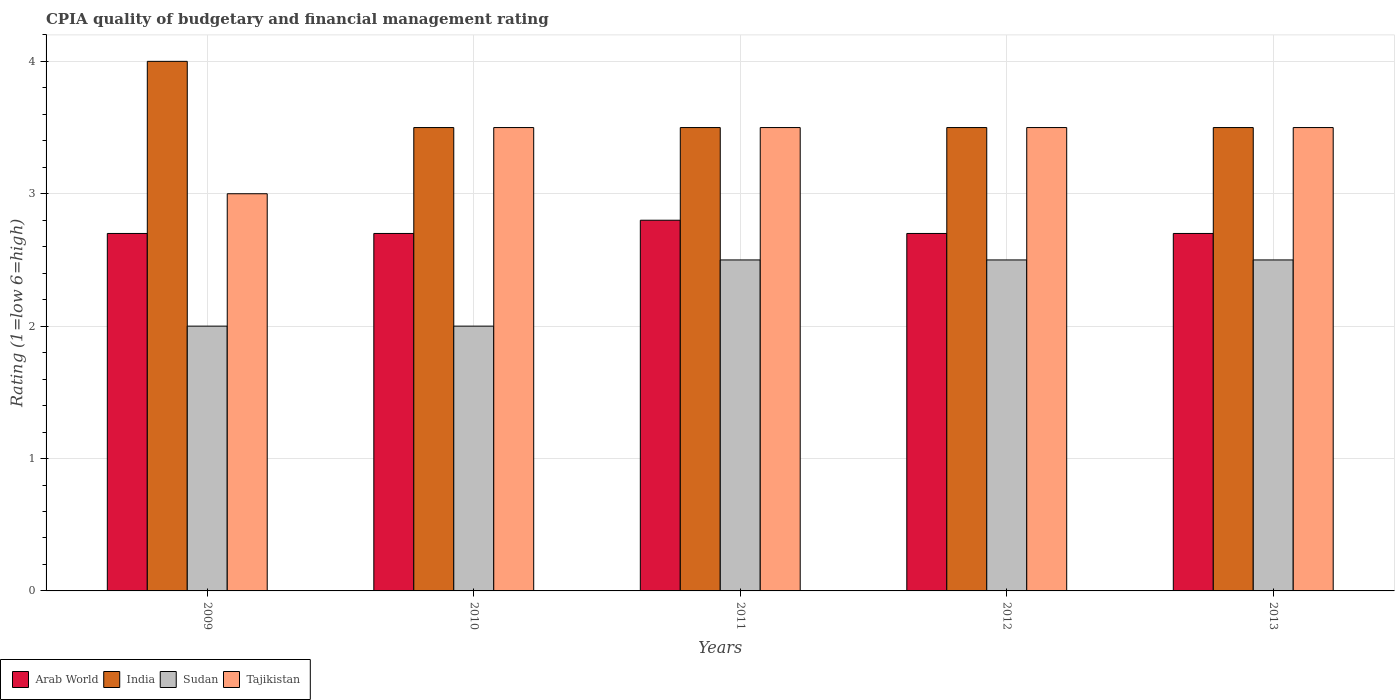How many groups of bars are there?
Make the answer very short. 5. How many bars are there on the 4th tick from the left?
Keep it short and to the point. 4. How many bars are there on the 1st tick from the right?
Your answer should be compact. 4. In how many cases, is the number of bars for a given year not equal to the number of legend labels?
Offer a very short reply. 0. Across all years, what is the minimum CPIA rating in Tajikistan?
Ensure brevity in your answer.  3. In which year was the CPIA rating in India maximum?
Offer a very short reply. 2009. What is the total CPIA rating in Tajikistan in the graph?
Give a very brief answer. 17. What is the difference between the CPIA rating in India in 2010 and that in 2013?
Provide a succinct answer. 0. What is the difference between the CPIA rating in India in 2012 and the CPIA rating in Arab World in 2013?
Make the answer very short. 0.8. What is the ratio of the CPIA rating in Tajikistan in 2009 to that in 2011?
Offer a very short reply. 0.86. Is the CPIA rating in Tajikistan in 2011 less than that in 2013?
Make the answer very short. No. Is the difference between the CPIA rating in Sudan in 2009 and 2011 greater than the difference between the CPIA rating in India in 2009 and 2011?
Give a very brief answer. No. What is the difference between the highest and the second highest CPIA rating in Arab World?
Provide a short and direct response. 0.1. Is it the case that in every year, the sum of the CPIA rating in Arab World and CPIA rating in Sudan is greater than the sum of CPIA rating in India and CPIA rating in Tajikistan?
Ensure brevity in your answer.  No. What does the 4th bar from the left in 2009 represents?
Provide a succinct answer. Tajikistan. What does the 2nd bar from the right in 2010 represents?
Offer a terse response. Sudan. How many years are there in the graph?
Provide a succinct answer. 5. What is the difference between two consecutive major ticks on the Y-axis?
Offer a very short reply. 1. Does the graph contain any zero values?
Offer a terse response. No. Where does the legend appear in the graph?
Give a very brief answer. Bottom left. What is the title of the graph?
Make the answer very short. CPIA quality of budgetary and financial management rating. Does "Luxembourg" appear as one of the legend labels in the graph?
Ensure brevity in your answer.  No. What is the label or title of the Y-axis?
Your answer should be compact. Rating (1=low 6=high). What is the Rating (1=low 6=high) of Arab World in 2009?
Offer a terse response. 2.7. What is the Rating (1=low 6=high) in India in 2009?
Your answer should be compact. 4. What is the Rating (1=low 6=high) of Sudan in 2009?
Your answer should be compact. 2. What is the Rating (1=low 6=high) of Arab World in 2010?
Your response must be concise. 2.7. What is the Rating (1=low 6=high) of India in 2010?
Give a very brief answer. 3.5. What is the Rating (1=low 6=high) in Sudan in 2010?
Your answer should be compact. 2. What is the Rating (1=low 6=high) in Tajikistan in 2010?
Ensure brevity in your answer.  3.5. What is the Rating (1=low 6=high) in India in 2011?
Your answer should be compact. 3.5. What is the Rating (1=low 6=high) of Sudan in 2011?
Provide a short and direct response. 2.5. What is the Rating (1=low 6=high) in Tajikistan in 2011?
Ensure brevity in your answer.  3.5. What is the Rating (1=low 6=high) in Sudan in 2012?
Keep it short and to the point. 2.5. What is the Rating (1=low 6=high) of Tajikistan in 2012?
Make the answer very short. 3.5. What is the Rating (1=low 6=high) of Arab World in 2013?
Make the answer very short. 2.7. What is the Rating (1=low 6=high) of India in 2013?
Provide a succinct answer. 3.5. Across all years, what is the maximum Rating (1=low 6=high) of Arab World?
Make the answer very short. 2.8. Across all years, what is the maximum Rating (1=low 6=high) of India?
Give a very brief answer. 4. Across all years, what is the minimum Rating (1=low 6=high) in India?
Your answer should be compact. 3.5. Across all years, what is the minimum Rating (1=low 6=high) of Tajikistan?
Offer a very short reply. 3. What is the total Rating (1=low 6=high) of Arab World in the graph?
Provide a short and direct response. 13.6. What is the total Rating (1=low 6=high) of Sudan in the graph?
Your response must be concise. 11.5. What is the total Rating (1=low 6=high) in Tajikistan in the graph?
Keep it short and to the point. 17. What is the difference between the Rating (1=low 6=high) of Arab World in 2009 and that in 2010?
Your answer should be very brief. 0. What is the difference between the Rating (1=low 6=high) in Sudan in 2009 and that in 2010?
Make the answer very short. 0. What is the difference between the Rating (1=low 6=high) of India in 2009 and that in 2011?
Make the answer very short. 0.5. What is the difference between the Rating (1=low 6=high) in Sudan in 2009 and that in 2012?
Provide a short and direct response. -0.5. What is the difference between the Rating (1=low 6=high) of Tajikistan in 2009 and that in 2012?
Offer a terse response. -0.5. What is the difference between the Rating (1=low 6=high) in India in 2009 and that in 2013?
Offer a very short reply. 0.5. What is the difference between the Rating (1=low 6=high) of India in 2010 and that in 2011?
Ensure brevity in your answer.  0. What is the difference between the Rating (1=low 6=high) of India in 2010 and that in 2012?
Make the answer very short. 0. What is the difference between the Rating (1=low 6=high) of Arab World in 2010 and that in 2013?
Offer a very short reply. 0. What is the difference between the Rating (1=low 6=high) in Arab World in 2011 and that in 2013?
Provide a short and direct response. 0.1. What is the difference between the Rating (1=low 6=high) of India in 2011 and that in 2013?
Offer a very short reply. 0. What is the difference between the Rating (1=low 6=high) of Arab World in 2012 and that in 2013?
Your answer should be very brief. 0. What is the difference between the Rating (1=low 6=high) in India in 2012 and that in 2013?
Provide a succinct answer. 0. What is the difference between the Rating (1=low 6=high) of Tajikistan in 2012 and that in 2013?
Keep it short and to the point. 0. What is the difference between the Rating (1=low 6=high) of Arab World in 2009 and the Rating (1=low 6=high) of India in 2010?
Offer a terse response. -0.8. What is the difference between the Rating (1=low 6=high) of Arab World in 2009 and the Rating (1=low 6=high) of Sudan in 2010?
Your answer should be very brief. 0.7. What is the difference between the Rating (1=low 6=high) in Arab World in 2009 and the Rating (1=low 6=high) in Tajikistan in 2010?
Keep it short and to the point. -0.8. What is the difference between the Rating (1=low 6=high) of Arab World in 2009 and the Rating (1=low 6=high) of India in 2011?
Offer a very short reply. -0.8. What is the difference between the Rating (1=low 6=high) of India in 2009 and the Rating (1=low 6=high) of Sudan in 2011?
Keep it short and to the point. 1.5. What is the difference between the Rating (1=low 6=high) of India in 2009 and the Rating (1=low 6=high) of Tajikistan in 2011?
Make the answer very short. 0.5. What is the difference between the Rating (1=low 6=high) of Sudan in 2009 and the Rating (1=low 6=high) of Tajikistan in 2011?
Make the answer very short. -1.5. What is the difference between the Rating (1=low 6=high) in Arab World in 2009 and the Rating (1=low 6=high) in Sudan in 2012?
Your answer should be compact. 0.2. What is the difference between the Rating (1=low 6=high) of Arab World in 2009 and the Rating (1=low 6=high) of Tajikistan in 2012?
Provide a succinct answer. -0.8. What is the difference between the Rating (1=low 6=high) of India in 2009 and the Rating (1=low 6=high) of Sudan in 2012?
Your response must be concise. 1.5. What is the difference between the Rating (1=low 6=high) in Sudan in 2009 and the Rating (1=low 6=high) in Tajikistan in 2012?
Your answer should be compact. -1.5. What is the difference between the Rating (1=low 6=high) in Arab World in 2009 and the Rating (1=low 6=high) in Sudan in 2013?
Give a very brief answer. 0.2. What is the difference between the Rating (1=low 6=high) in Arab World in 2009 and the Rating (1=low 6=high) in Tajikistan in 2013?
Your answer should be very brief. -0.8. What is the difference between the Rating (1=low 6=high) of India in 2009 and the Rating (1=low 6=high) of Sudan in 2013?
Your answer should be compact. 1.5. What is the difference between the Rating (1=low 6=high) of India in 2009 and the Rating (1=low 6=high) of Tajikistan in 2013?
Your response must be concise. 0.5. What is the difference between the Rating (1=low 6=high) in Sudan in 2009 and the Rating (1=low 6=high) in Tajikistan in 2013?
Offer a terse response. -1.5. What is the difference between the Rating (1=low 6=high) in Arab World in 2010 and the Rating (1=low 6=high) in India in 2011?
Your response must be concise. -0.8. What is the difference between the Rating (1=low 6=high) of Arab World in 2010 and the Rating (1=low 6=high) of Tajikistan in 2011?
Offer a terse response. -0.8. What is the difference between the Rating (1=low 6=high) in India in 2010 and the Rating (1=low 6=high) in Sudan in 2011?
Your answer should be compact. 1. What is the difference between the Rating (1=low 6=high) of India in 2010 and the Rating (1=low 6=high) of Tajikistan in 2011?
Your response must be concise. 0. What is the difference between the Rating (1=low 6=high) of Arab World in 2010 and the Rating (1=low 6=high) of India in 2012?
Offer a terse response. -0.8. What is the difference between the Rating (1=low 6=high) of Arab World in 2010 and the Rating (1=low 6=high) of Sudan in 2012?
Keep it short and to the point. 0.2. What is the difference between the Rating (1=low 6=high) in India in 2010 and the Rating (1=low 6=high) in Sudan in 2012?
Ensure brevity in your answer.  1. What is the difference between the Rating (1=low 6=high) of Arab World in 2010 and the Rating (1=low 6=high) of India in 2013?
Give a very brief answer. -0.8. What is the difference between the Rating (1=low 6=high) in India in 2010 and the Rating (1=low 6=high) in Sudan in 2013?
Ensure brevity in your answer.  1. What is the difference between the Rating (1=low 6=high) of India in 2010 and the Rating (1=low 6=high) of Tajikistan in 2013?
Provide a short and direct response. 0. What is the difference between the Rating (1=low 6=high) of Sudan in 2010 and the Rating (1=low 6=high) of Tajikistan in 2013?
Keep it short and to the point. -1.5. What is the difference between the Rating (1=low 6=high) of Arab World in 2011 and the Rating (1=low 6=high) of India in 2012?
Make the answer very short. -0.7. What is the difference between the Rating (1=low 6=high) of Arab World in 2011 and the Rating (1=low 6=high) of Sudan in 2012?
Provide a short and direct response. 0.3. What is the difference between the Rating (1=low 6=high) of Arab World in 2011 and the Rating (1=low 6=high) of Tajikistan in 2012?
Your answer should be very brief. -0.7. What is the difference between the Rating (1=low 6=high) in India in 2011 and the Rating (1=low 6=high) in Tajikistan in 2012?
Your response must be concise. 0. What is the difference between the Rating (1=low 6=high) of Sudan in 2011 and the Rating (1=low 6=high) of Tajikistan in 2012?
Ensure brevity in your answer.  -1. What is the difference between the Rating (1=low 6=high) in Arab World in 2011 and the Rating (1=low 6=high) in India in 2013?
Your answer should be compact. -0.7. What is the difference between the Rating (1=low 6=high) in Arab World in 2011 and the Rating (1=low 6=high) in Tajikistan in 2013?
Provide a succinct answer. -0.7. What is the difference between the Rating (1=low 6=high) of India in 2011 and the Rating (1=low 6=high) of Sudan in 2013?
Make the answer very short. 1. What is the difference between the Rating (1=low 6=high) in India in 2011 and the Rating (1=low 6=high) in Tajikistan in 2013?
Give a very brief answer. 0. What is the difference between the Rating (1=low 6=high) in Arab World in 2012 and the Rating (1=low 6=high) in India in 2013?
Your answer should be compact. -0.8. What is the difference between the Rating (1=low 6=high) in India in 2012 and the Rating (1=low 6=high) in Sudan in 2013?
Offer a very short reply. 1. What is the difference between the Rating (1=low 6=high) in India in 2012 and the Rating (1=low 6=high) in Tajikistan in 2013?
Your answer should be very brief. 0. What is the difference between the Rating (1=low 6=high) of Sudan in 2012 and the Rating (1=low 6=high) of Tajikistan in 2013?
Your response must be concise. -1. What is the average Rating (1=low 6=high) in Arab World per year?
Provide a short and direct response. 2.72. What is the average Rating (1=low 6=high) of Sudan per year?
Offer a terse response. 2.3. In the year 2009, what is the difference between the Rating (1=low 6=high) in Arab World and Rating (1=low 6=high) in Sudan?
Provide a short and direct response. 0.7. In the year 2009, what is the difference between the Rating (1=low 6=high) of India and Rating (1=low 6=high) of Tajikistan?
Give a very brief answer. 1. In the year 2010, what is the difference between the Rating (1=low 6=high) of Arab World and Rating (1=low 6=high) of Sudan?
Offer a very short reply. 0.7. In the year 2010, what is the difference between the Rating (1=low 6=high) in Arab World and Rating (1=low 6=high) in Tajikistan?
Provide a succinct answer. -0.8. In the year 2010, what is the difference between the Rating (1=low 6=high) of India and Rating (1=low 6=high) of Sudan?
Offer a very short reply. 1.5. In the year 2011, what is the difference between the Rating (1=low 6=high) of India and Rating (1=low 6=high) of Sudan?
Give a very brief answer. 1. In the year 2011, what is the difference between the Rating (1=low 6=high) in India and Rating (1=low 6=high) in Tajikistan?
Your response must be concise. 0. In the year 2011, what is the difference between the Rating (1=low 6=high) of Sudan and Rating (1=low 6=high) of Tajikistan?
Provide a short and direct response. -1. In the year 2012, what is the difference between the Rating (1=low 6=high) of Arab World and Rating (1=low 6=high) of India?
Offer a very short reply. -0.8. In the year 2012, what is the difference between the Rating (1=low 6=high) in Arab World and Rating (1=low 6=high) in Tajikistan?
Provide a short and direct response. -0.8. In the year 2012, what is the difference between the Rating (1=low 6=high) of India and Rating (1=low 6=high) of Sudan?
Ensure brevity in your answer.  1. In the year 2012, what is the difference between the Rating (1=low 6=high) in Sudan and Rating (1=low 6=high) in Tajikistan?
Provide a succinct answer. -1. In the year 2013, what is the difference between the Rating (1=low 6=high) of Arab World and Rating (1=low 6=high) of Tajikistan?
Offer a very short reply. -0.8. In the year 2013, what is the difference between the Rating (1=low 6=high) of Sudan and Rating (1=low 6=high) of Tajikistan?
Give a very brief answer. -1. What is the ratio of the Rating (1=low 6=high) in Arab World in 2009 to that in 2010?
Give a very brief answer. 1. What is the ratio of the Rating (1=low 6=high) of Sudan in 2009 to that in 2010?
Your answer should be very brief. 1. What is the ratio of the Rating (1=low 6=high) in Sudan in 2009 to that in 2011?
Provide a succinct answer. 0.8. What is the ratio of the Rating (1=low 6=high) of Tajikistan in 2009 to that in 2011?
Keep it short and to the point. 0.86. What is the ratio of the Rating (1=low 6=high) of Arab World in 2009 to that in 2012?
Your answer should be compact. 1. What is the ratio of the Rating (1=low 6=high) of India in 2009 to that in 2012?
Provide a short and direct response. 1.14. What is the ratio of the Rating (1=low 6=high) of Sudan in 2009 to that in 2012?
Offer a terse response. 0.8. What is the ratio of the Rating (1=low 6=high) in Arab World in 2010 to that in 2011?
Your answer should be very brief. 0.96. What is the ratio of the Rating (1=low 6=high) of India in 2010 to that in 2011?
Offer a terse response. 1. What is the ratio of the Rating (1=low 6=high) in Sudan in 2010 to that in 2011?
Provide a succinct answer. 0.8. What is the ratio of the Rating (1=low 6=high) in Tajikistan in 2010 to that in 2011?
Your answer should be compact. 1. What is the ratio of the Rating (1=low 6=high) in India in 2010 to that in 2012?
Your response must be concise. 1. What is the ratio of the Rating (1=low 6=high) of Tajikistan in 2010 to that in 2012?
Your response must be concise. 1. What is the ratio of the Rating (1=low 6=high) in Arab World in 2010 to that in 2013?
Offer a very short reply. 1. What is the ratio of the Rating (1=low 6=high) of Sudan in 2010 to that in 2013?
Ensure brevity in your answer.  0.8. What is the ratio of the Rating (1=low 6=high) in Tajikistan in 2010 to that in 2013?
Keep it short and to the point. 1. What is the ratio of the Rating (1=low 6=high) in India in 2011 to that in 2012?
Give a very brief answer. 1. What is the ratio of the Rating (1=low 6=high) of Sudan in 2011 to that in 2012?
Keep it short and to the point. 1. What is the ratio of the Rating (1=low 6=high) in Tajikistan in 2011 to that in 2012?
Provide a short and direct response. 1. What is the ratio of the Rating (1=low 6=high) of Tajikistan in 2011 to that in 2013?
Provide a succinct answer. 1. What is the ratio of the Rating (1=low 6=high) of Arab World in 2012 to that in 2013?
Keep it short and to the point. 1. What is the ratio of the Rating (1=low 6=high) of India in 2012 to that in 2013?
Your answer should be very brief. 1. What is the ratio of the Rating (1=low 6=high) of Sudan in 2012 to that in 2013?
Provide a short and direct response. 1. What is the difference between the highest and the second highest Rating (1=low 6=high) of Arab World?
Provide a succinct answer. 0.1. What is the difference between the highest and the second highest Rating (1=low 6=high) of India?
Make the answer very short. 0.5. What is the difference between the highest and the second highest Rating (1=low 6=high) of Tajikistan?
Keep it short and to the point. 0. What is the difference between the highest and the lowest Rating (1=low 6=high) of Arab World?
Make the answer very short. 0.1. What is the difference between the highest and the lowest Rating (1=low 6=high) in Sudan?
Ensure brevity in your answer.  0.5. What is the difference between the highest and the lowest Rating (1=low 6=high) in Tajikistan?
Make the answer very short. 0.5. 